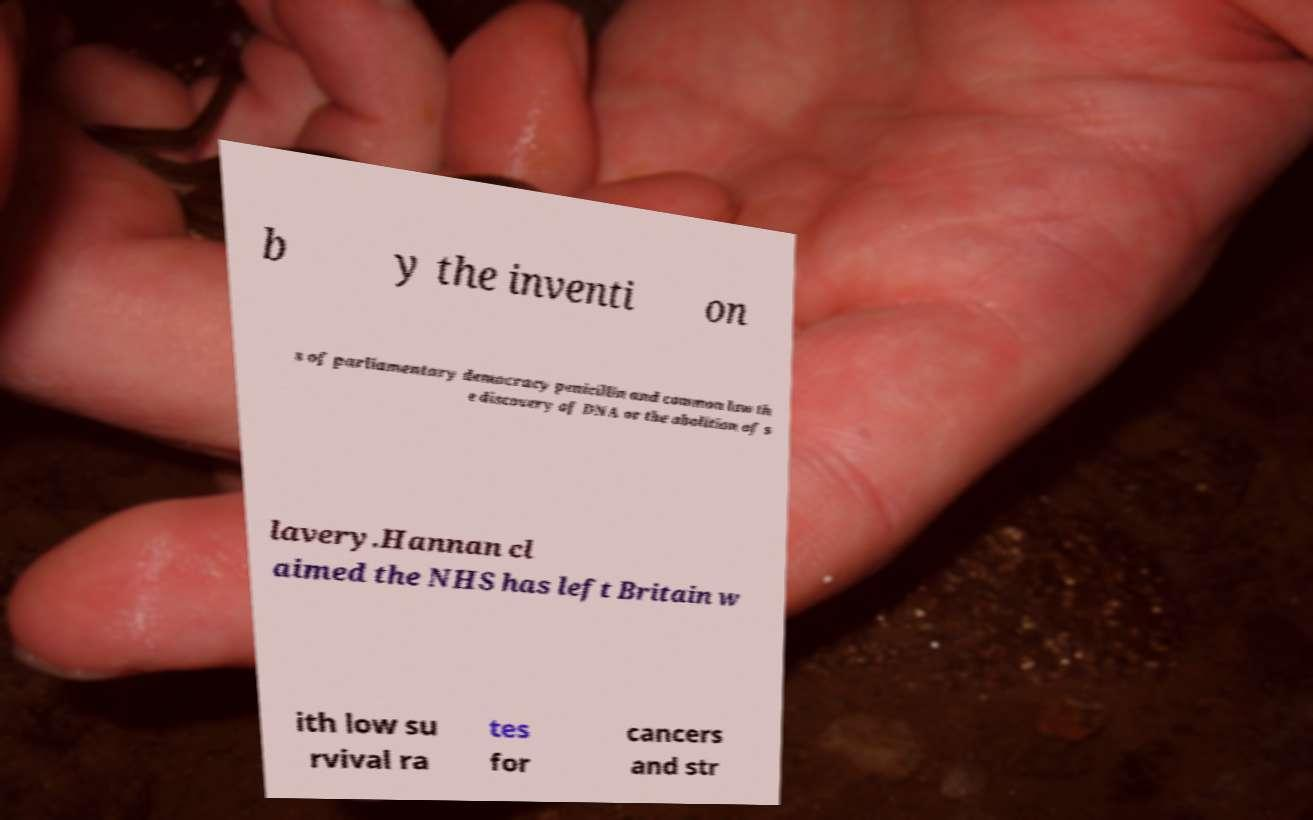For documentation purposes, I need the text within this image transcribed. Could you provide that? b y the inventi on s of parliamentary democracy penicillin and common law th e discovery of DNA or the abolition of s lavery.Hannan cl aimed the NHS has left Britain w ith low su rvival ra tes for cancers and str 